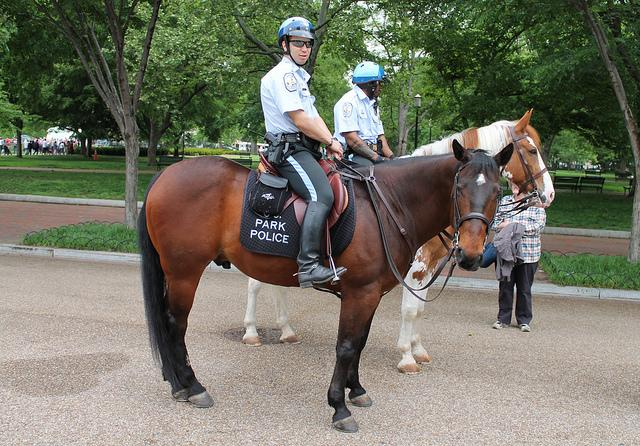Where are these policemen patrolling?

Choices:
A) inside park
B) at airport
C) in city
D) tourist zone inside park 